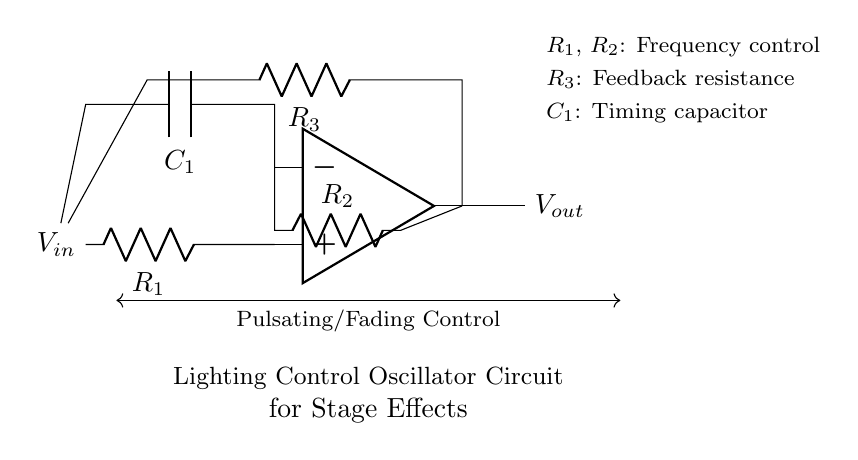What is the purpose of the capacitor in this circuit? The capacitor, labeled as C1 in the circuit, is used for timing. It determines how the circuit oscillates by charging and discharging, which plays a key role in creating the pulsating or fading light effects.
Answer: Timing What are the values represented by R1 and R2? R1 and R2 are both labeled as resistors in the circuit diagram, and they primarily control the frequency of the oscillation. The values of these resistors affect how quickly the capacitor can charge and discharge, thus impacting the periodicity of the light effects.
Answer: Frequency control Which component is responsible for feedback in this oscillator? The feedback resistance in the oscillator is provided by R3. This resistor plays a crucial role in stabilizing the oscillation by returning a portion of the output signal back to the input.
Answer: R3 How does changing R1 affect the circuit operation? Changing R1 alters the charging time of C1 and therefore changes the frequency of the oscillation. A higher resistance in R1 results in slower charging of the capacitor, making the pulses longer and slower. This affects the light effects that will be produced.
Answer: Frequency change Where does the input voltage enter the circuit? The input voltage, labeled as Vin, enters the circuit at the left side of R1, directly connecting to the positive terminal of the operational amplifier. This voltage initiates the signal processing in the circuit.
Answer: Vin What is the output voltage labeled in the circuit? The output voltage in the circuit is labeled as Vout. This is the voltage that will be used to control the lighting effects, based on the characteristics of the oscillation produced in the circuit.
Answer: Vout 